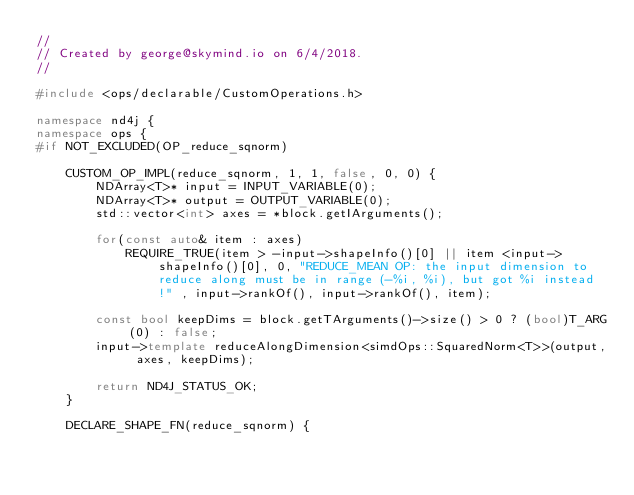<code> <loc_0><loc_0><loc_500><loc_500><_C++_>//
// Created by george@skymind.io on 6/4/2018.
//

#include <ops/declarable/CustomOperations.h>

namespace nd4j {
namespace ops {
#if NOT_EXCLUDED(OP_reduce_sqnorm)

    CUSTOM_OP_IMPL(reduce_sqnorm, 1, 1, false, 0, 0) {
        NDArray<T>* input = INPUT_VARIABLE(0);
        NDArray<T>* output = OUTPUT_VARIABLE(0);
        std::vector<int> axes = *block.getIArguments();

        for(const auto& item : axes)
            REQUIRE_TRUE(item > -input->shapeInfo()[0] || item <input->shapeInfo()[0], 0, "REDUCE_MEAN OP: the input dimension to reduce along must be in range (-%i, %i), but got %i instead !" , input->rankOf(), input->rankOf(), item);

        const bool keepDims = block.getTArguments()->size() > 0 ? (bool)T_ARG(0) : false;
        input->template reduceAlongDimension<simdOps::SquaredNorm<T>>(output, axes, keepDims);

        return ND4J_STATUS_OK;
    }

    DECLARE_SHAPE_FN(reduce_sqnorm) {    
</code> 